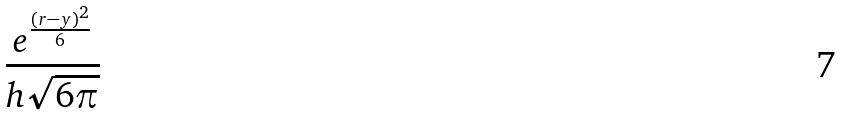<formula> <loc_0><loc_0><loc_500><loc_500>\frac { e ^ { \frac { ( r - y ) ^ { 2 } } { 6 } } } { h \sqrt { 6 \pi } }</formula> 